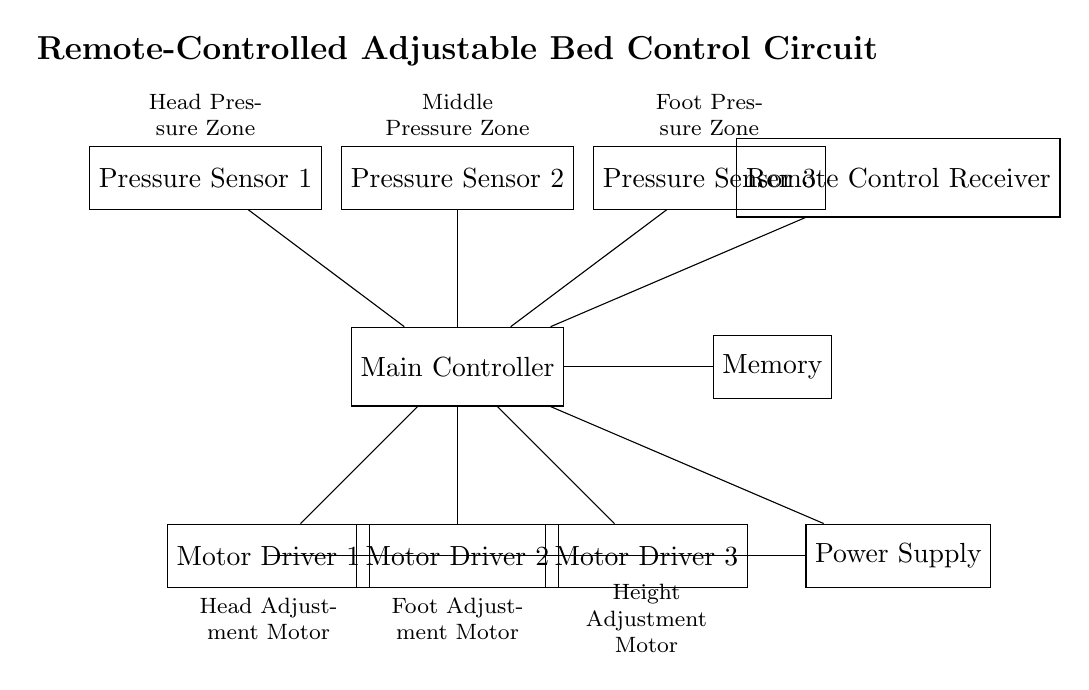What is the main component of this circuit? The main component shown is the Main Controller, which coordinates the functions of the bed's adjustments and sensors.
Answer: Main Controller How many motor drivers are present? There are three motor drivers, each controlling different adjustments of the bed: head, foot, and height.
Answer: Three What type of sensors are used in the circuit? The circuit includes pressure sensors, specifically designed to monitor pressure zones to enhance comfort and support.
Answer: Pressure sensors Which component receives signals from the remote control? The Remote Control Receiver component is responsible for receiving signals from the user's remote control, allowing for wireless operation.
Answer: Remote Control Receiver What is the function of the memory in this circuit? The Memory component stores user-defined positions, allowing quick adjustment to preferred positions with a single command.
Answer: Stores user-defined positions Which sensors are located above the main controller? Pressure sensors are placed above the Main Controller, indicating their role in monitoring the comfort pressure zones of the bed.
Answer: Pressure sensors 